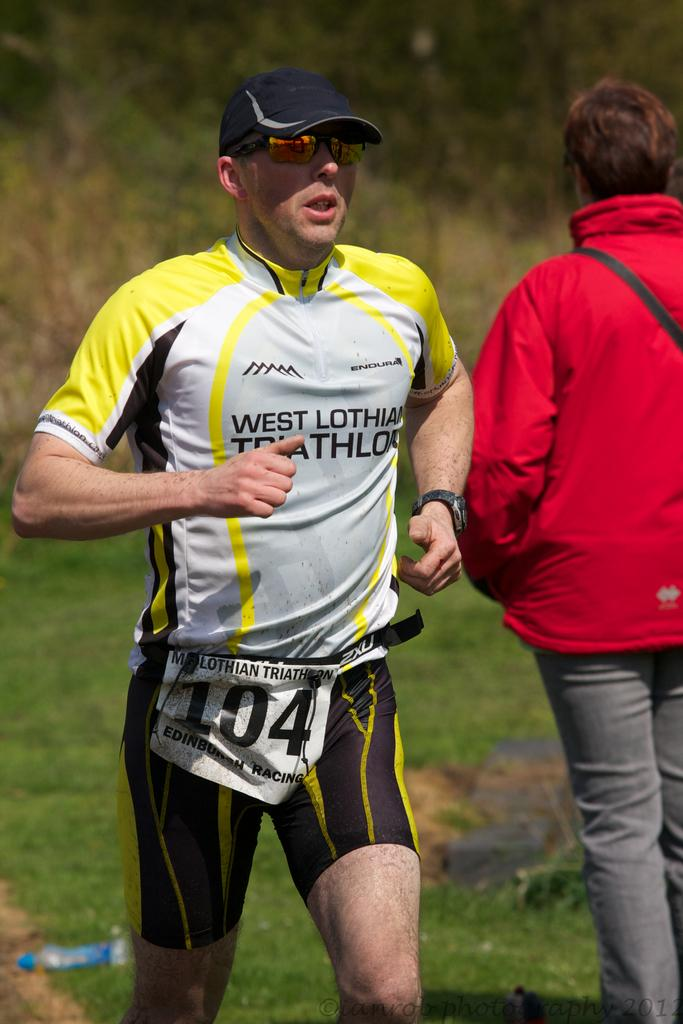What is the man in the image wearing on his head? The man in the image is wearing a cap. What is the man with the cap doing in the image? The man with the cap is running. Can you describe the other person in the image? The other person is wearing a red jacket and is on the right side of the man with a cap. What can be seen in the background of the image? Trees and grass are visible in the background of the image. What type of ink is being used by the cow in the image? There is no cow present in the image, and therefore no ink or ink-related activity can be observed. 